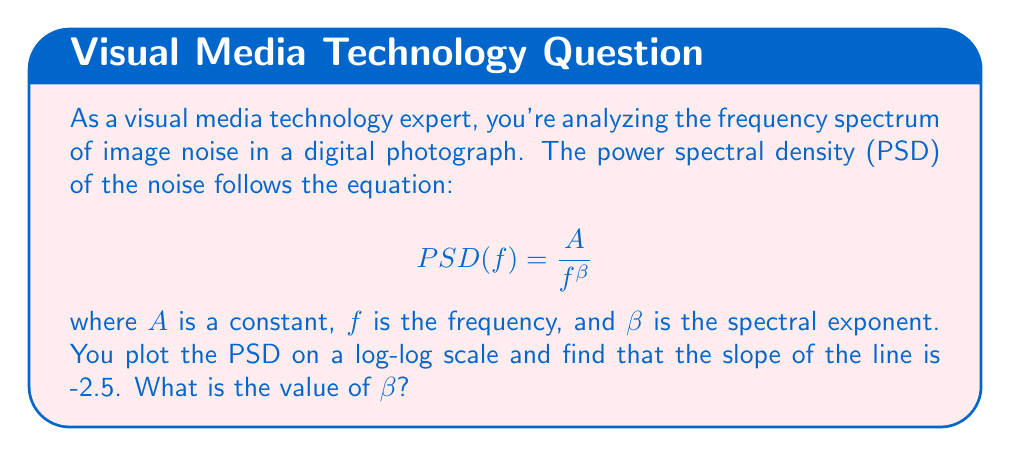Teach me how to tackle this problem. To solve this problem, we need to understand the relationship between the logarithmic plot and the original equation:

1. The equation of the PSD is in the form of a power law: $PSD(f) = \frac{A}{f^\beta}$

2. Taking the logarithm of both sides:
   $\log(PSD) = \log(A) - \beta \log(f)$

3. This is in the form of a linear equation: $y = mx + b$, where:
   - $y = \log(PSD)$
   - $x = \log(f)$
   - $m = -\beta$ (the slope)
   - $b = \log(A)$ (the y-intercept)

4. On a log-log plot, the slope of the line represents $-\beta$

5. We are given that the slope of the line is -2.5

6. Therefore:
   $-\beta = -2.5$
   $\beta = 2.5$

The spectral exponent $\beta$ is equal to the negative of the slope on the log-log plot.
Answer: $\beta = 2.5$ 